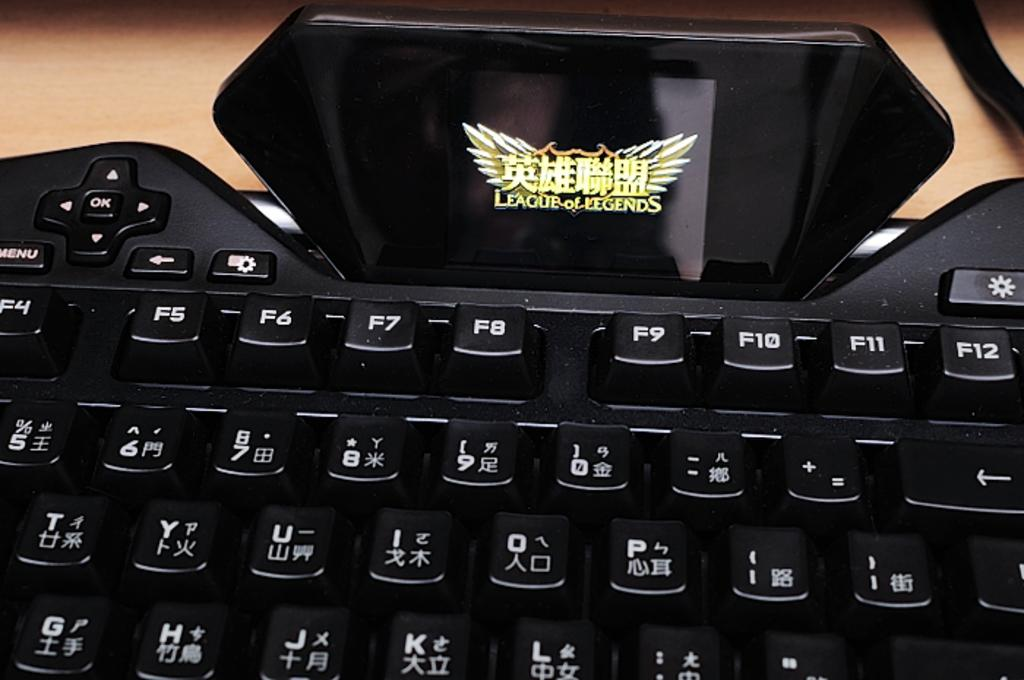<image>
Render a clear and concise summary of the photo. A black keyboard has a League of Legends logo on it. 